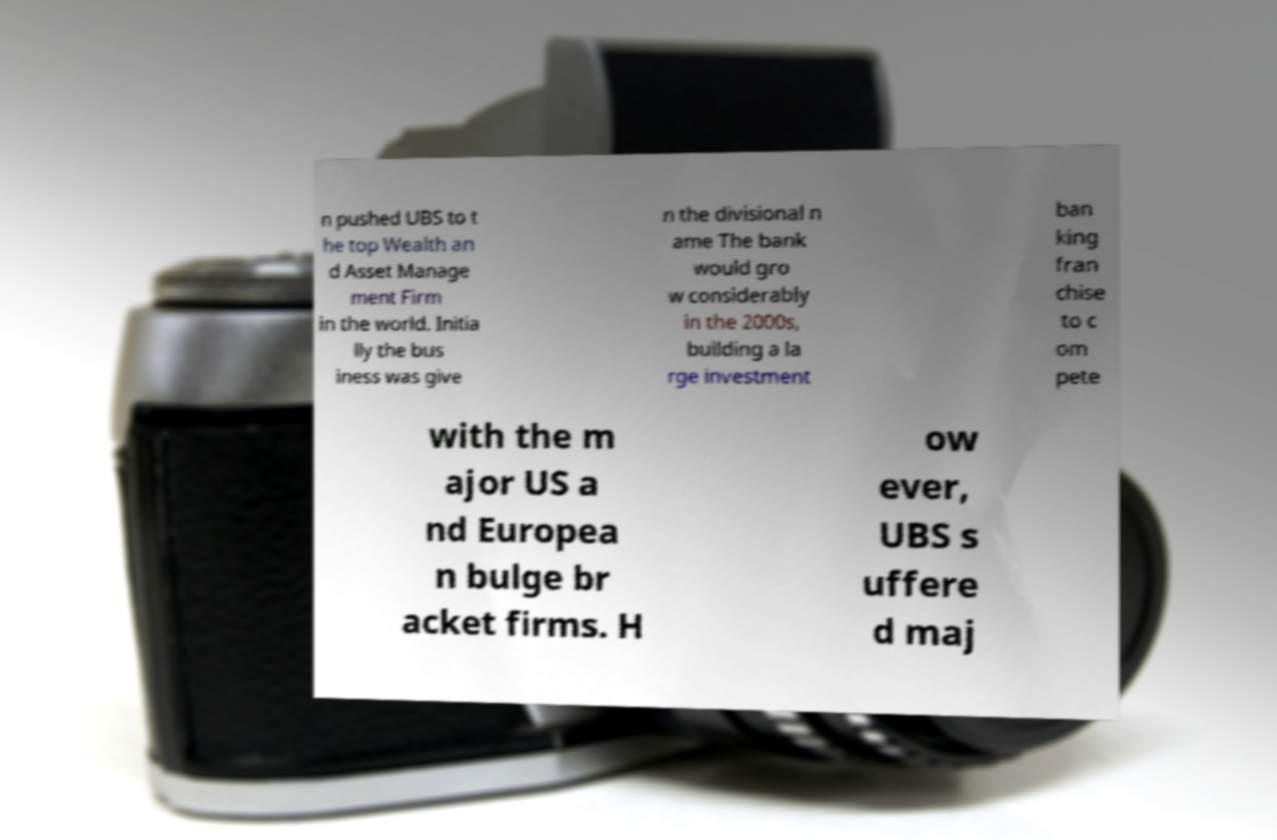Please identify and transcribe the text found in this image. n pushed UBS to t he top Wealth an d Asset Manage ment Firm in the world. Initia lly the bus iness was give n the divisional n ame The bank would gro w considerably in the 2000s, building a la rge investment ban king fran chise to c om pete with the m ajor US a nd Europea n bulge br acket firms. H ow ever, UBS s uffere d maj 